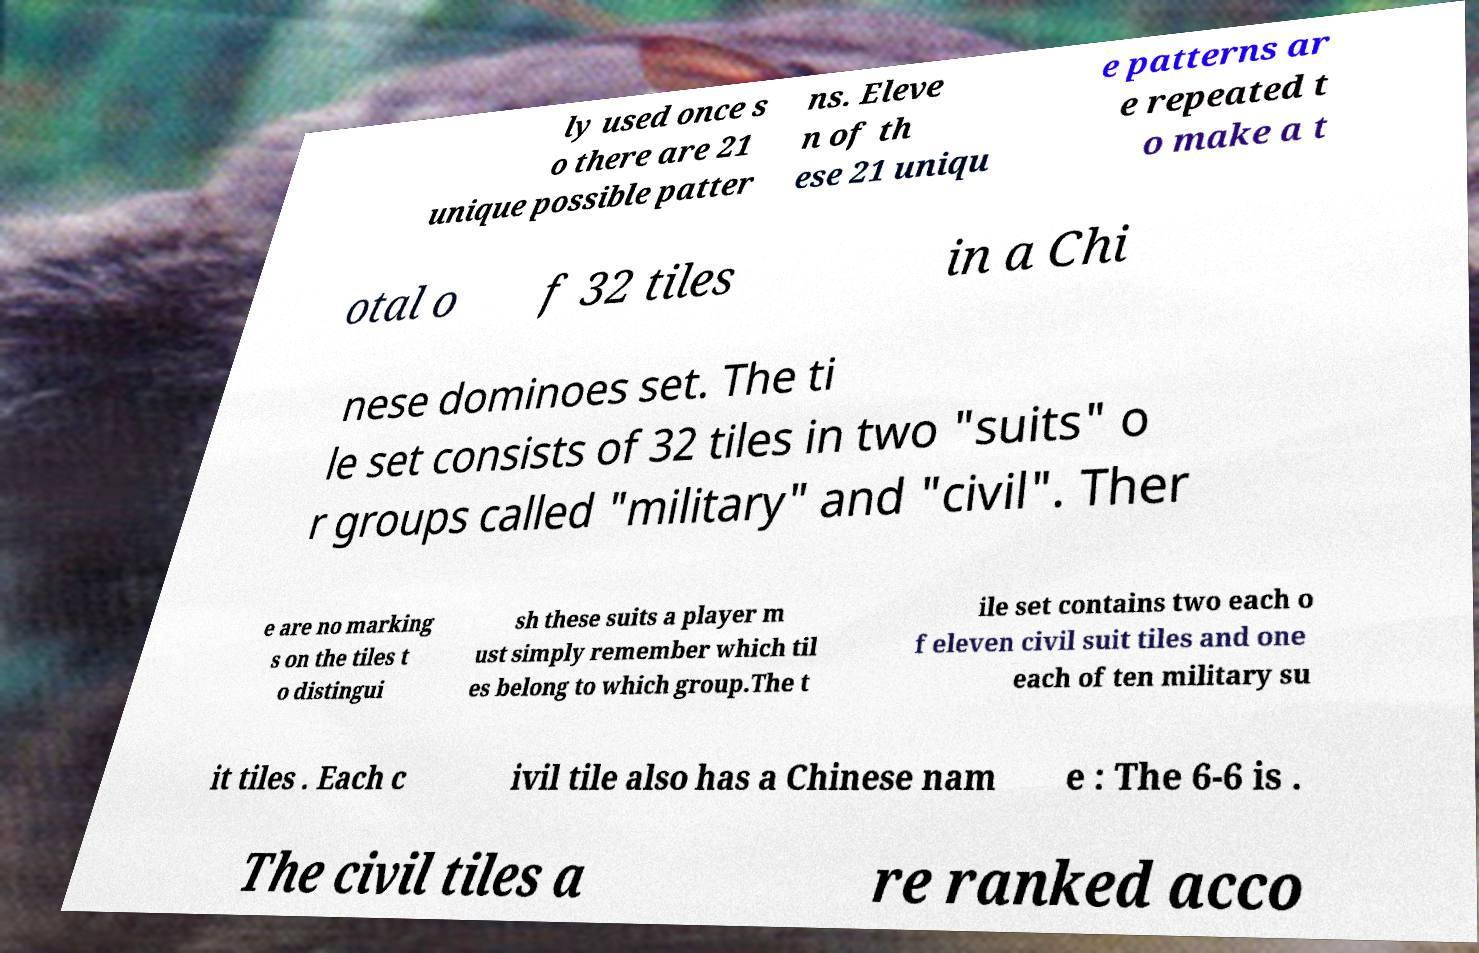Please identify and transcribe the text found in this image. ly used once s o there are 21 unique possible patter ns. Eleve n of th ese 21 uniqu e patterns ar e repeated t o make a t otal o f 32 tiles in a Chi nese dominoes set. The ti le set consists of 32 tiles in two "suits" o r groups called "military" and "civil". Ther e are no marking s on the tiles t o distingui sh these suits a player m ust simply remember which til es belong to which group.The t ile set contains two each o f eleven civil suit tiles and one each of ten military su it tiles . Each c ivil tile also has a Chinese nam e : The 6-6 is . The civil tiles a re ranked acco 